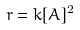<formula> <loc_0><loc_0><loc_500><loc_500>r = k [ A ] ^ { 2 }</formula> 